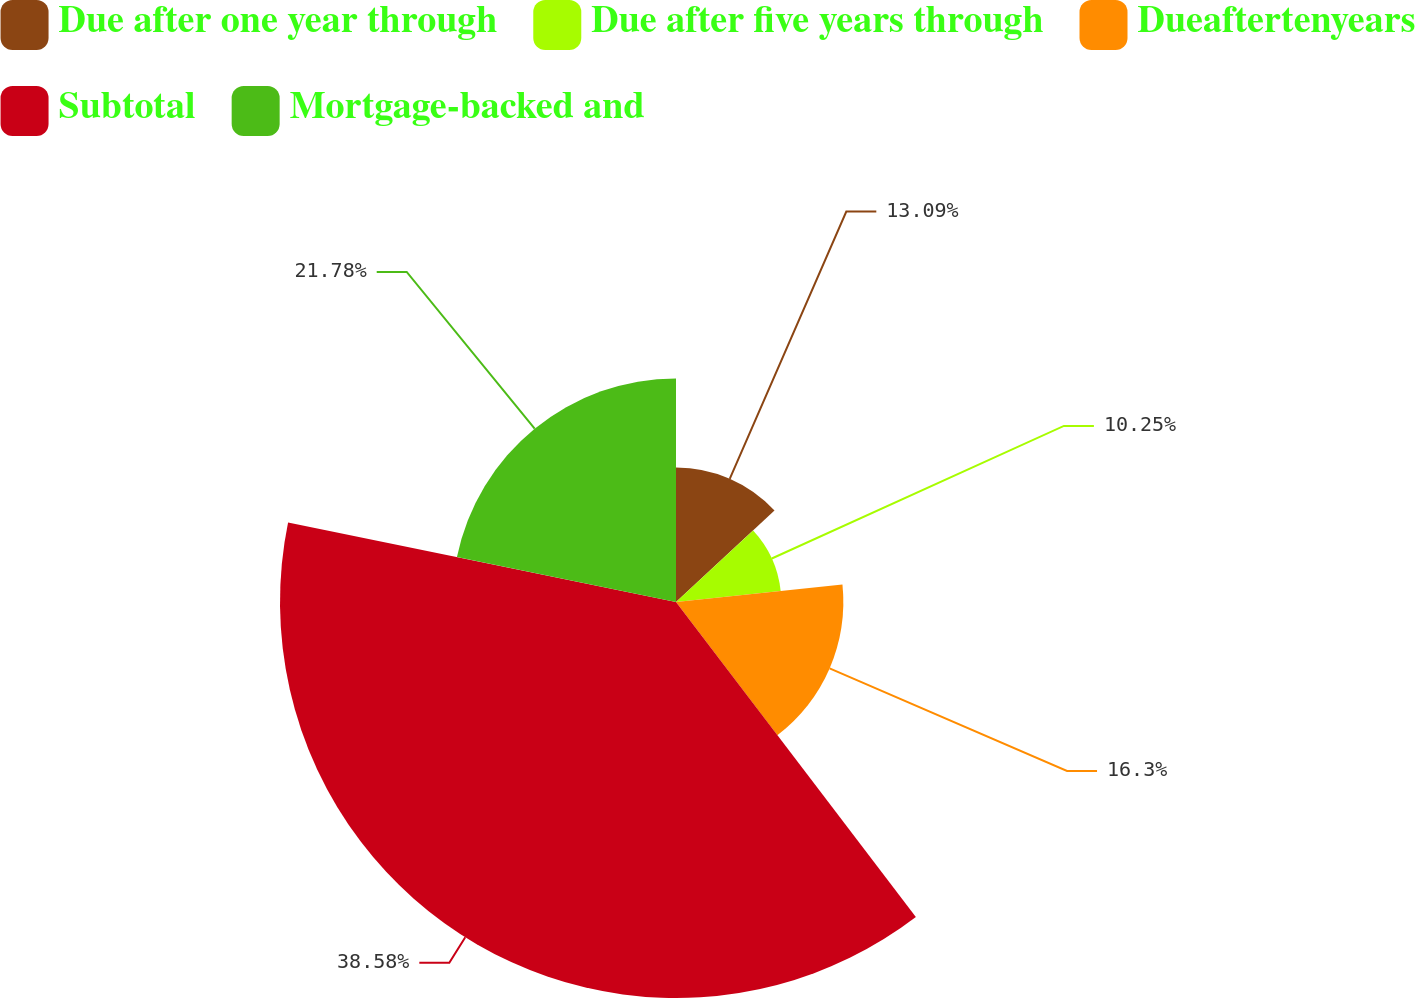Convert chart to OTSL. <chart><loc_0><loc_0><loc_500><loc_500><pie_chart><fcel>Due after one year through<fcel>Due after five years through<fcel>Dueaftertenyears<fcel>Subtotal<fcel>Mortgage-backed and<nl><fcel>13.09%<fcel>10.25%<fcel>16.3%<fcel>38.57%<fcel>21.78%<nl></chart> 